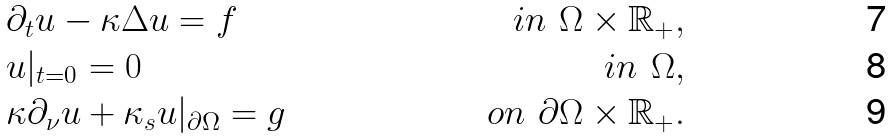Convert formula to latex. <formula><loc_0><loc_0><loc_500><loc_500>& \partial _ { t } u - \kappa \Delta u = f & i n \ \Omega \times \mathbb { R } _ { + } , \\ & u | _ { t = 0 } = 0 & i n \ \Omega , \\ & \kappa \partial _ { \nu } u + \kappa _ { s } u | _ { \partial \Omega } = g & o n \ \partial \Omega \times \mathbb { R } _ { + } .</formula> 